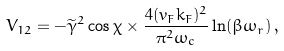<formula> <loc_0><loc_0><loc_500><loc_500>V _ { 1 2 } = - \widetilde { \gamma } ^ { 2 } \cos \chi \times \frac { 4 ( v _ { F } k _ { F } ) ^ { 2 } } { \pi ^ { 2 } \omega _ { c } } \ln ( \beta \omega _ { r } ) \, ,</formula> 